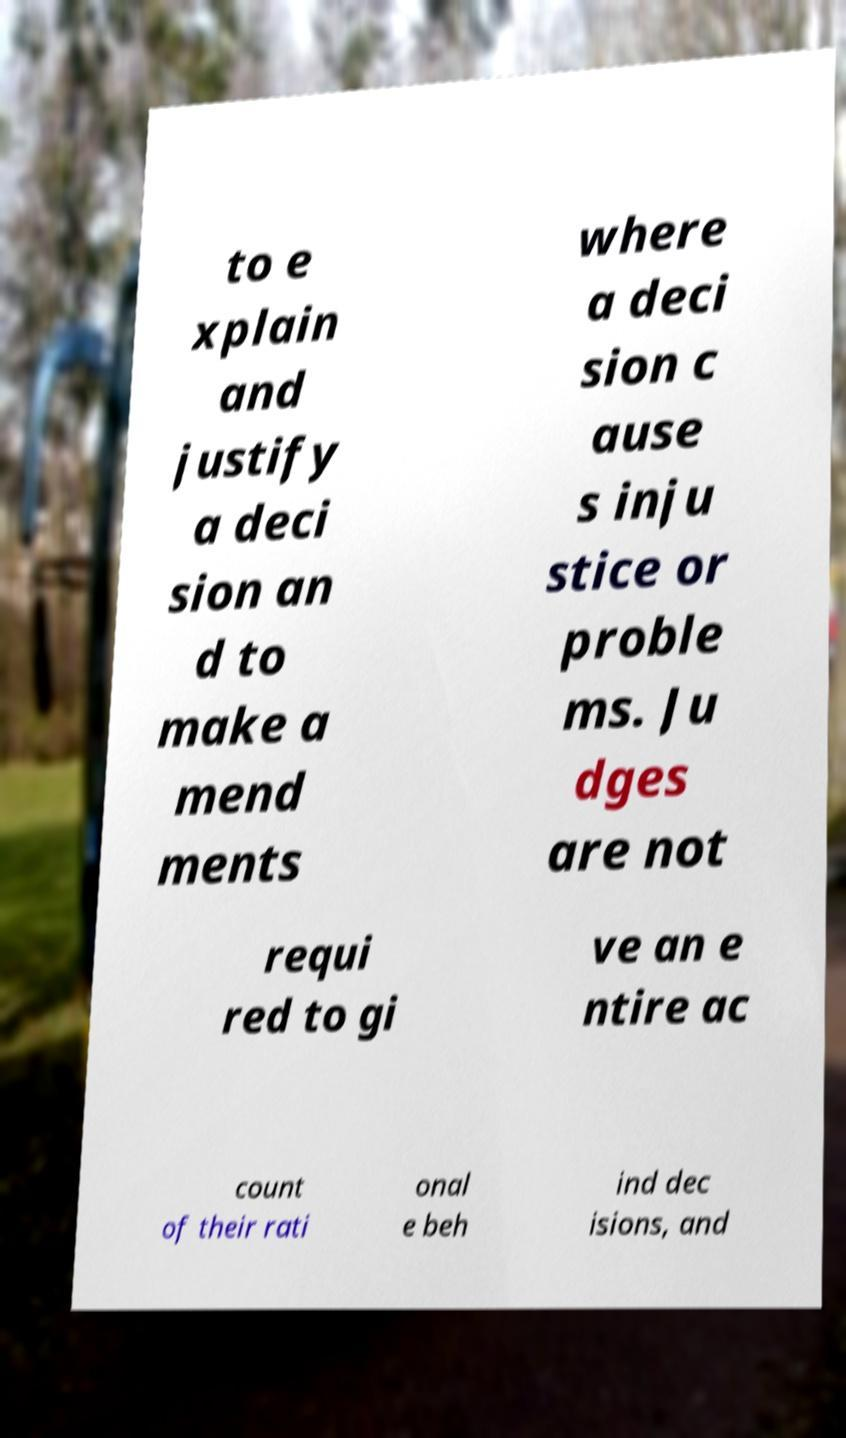Could you assist in decoding the text presented in this image and type it out clearly? to e xplain and justify a deci sion an d to make a mend ments where a deci sion c ause s inju stice or proble ms. Ju dges are not requi red to gi ve an e ntire ac count of their rati onal e beh ind dec isions, and 